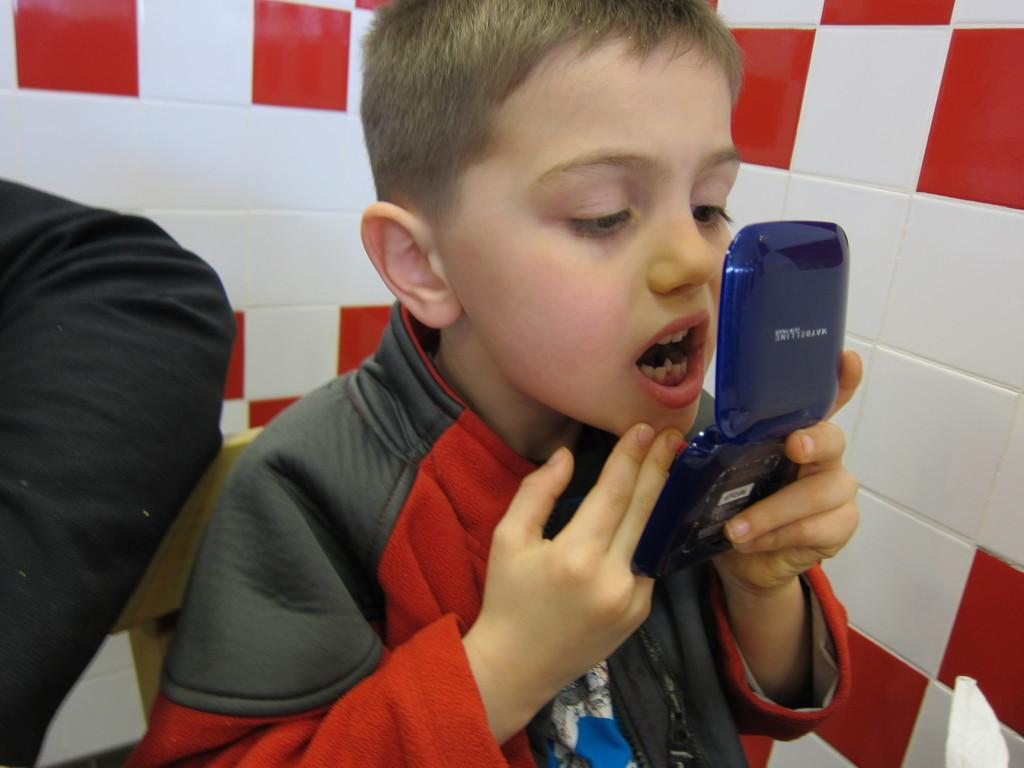Who is present in the image? There is a guy in the image. What is the guy doing in the image? The guy is looking at a mirror. What can be seen behind the guy in the image? There is a wall behind the guy. What colors are present on the wall in the image? The wall has red and black colors. What is the number of airplanes visible in the image? There are no airplanes present in the image. What part of the guy's body is missing in the image? The image does not show any missing parts of the guy's body; he appears to be complete. 